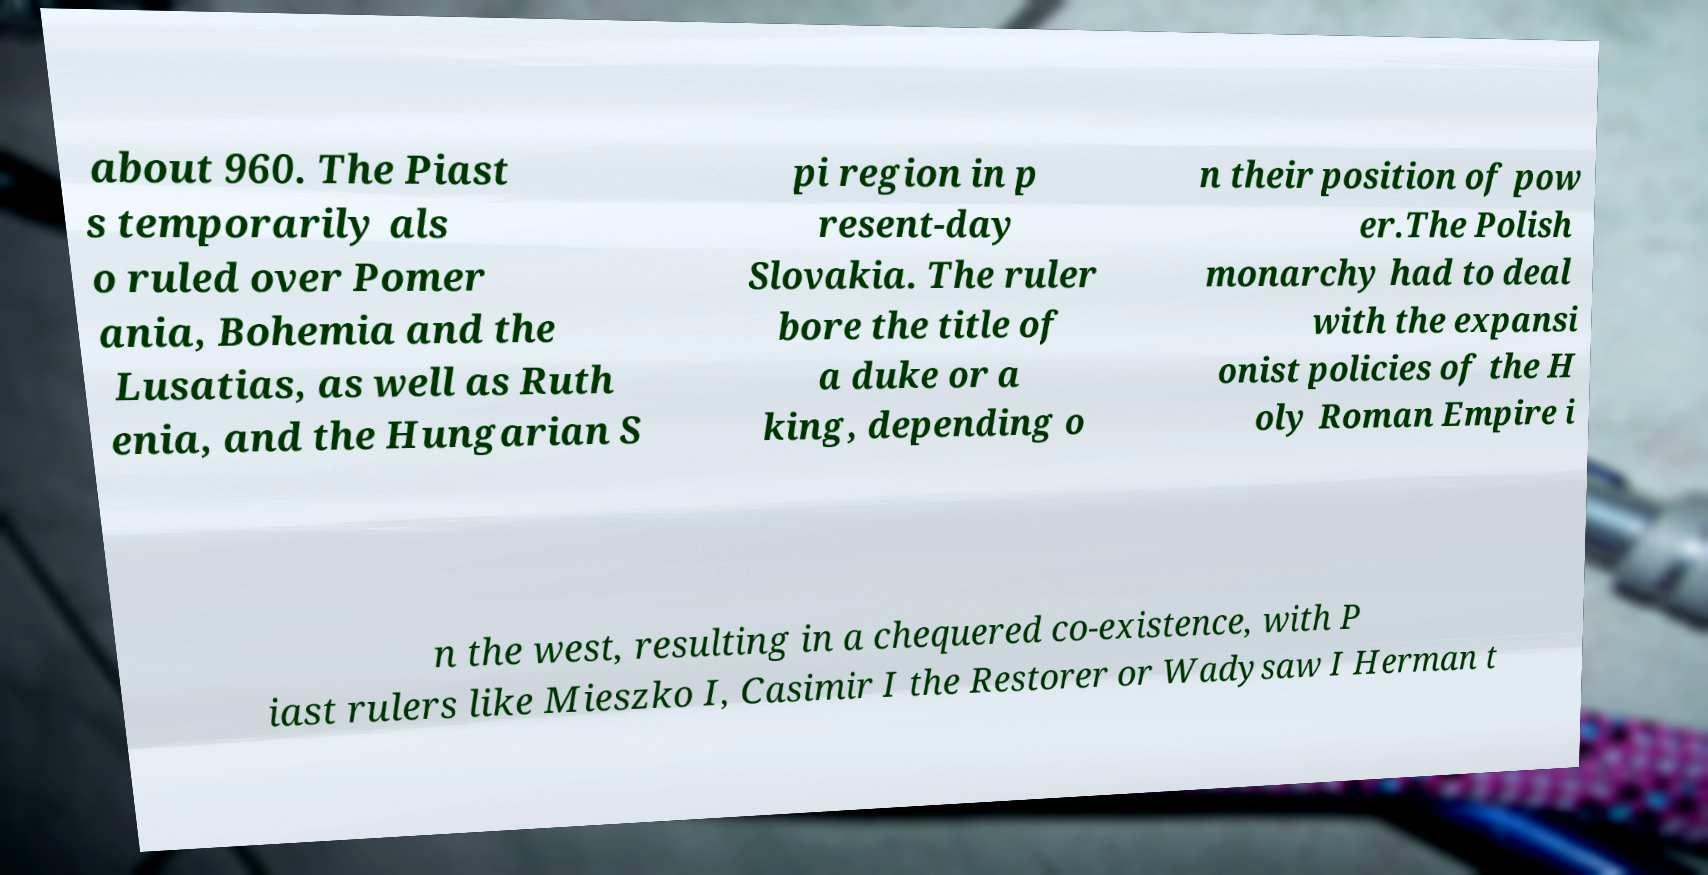Could you assist in decoding the text presented in this image and type it out clearly? about 960. The Piast s temporarily als o ruled over Pomer ania, Bohemia and the Lusatias, as well as Ruth enia, and the Hungarian S pi region in p resent-day Slovakia. The ruler bore the title of a duke or a king, depending o n their position of pow er.The Polish monarchy had to deal with the expansi onist policies of the H oly Roman Empire i n the west, resulting in a chequered co-existence, with P iast rulers like Mieszko I, Casimir I the Restorer or Wadysaw I Herman t 